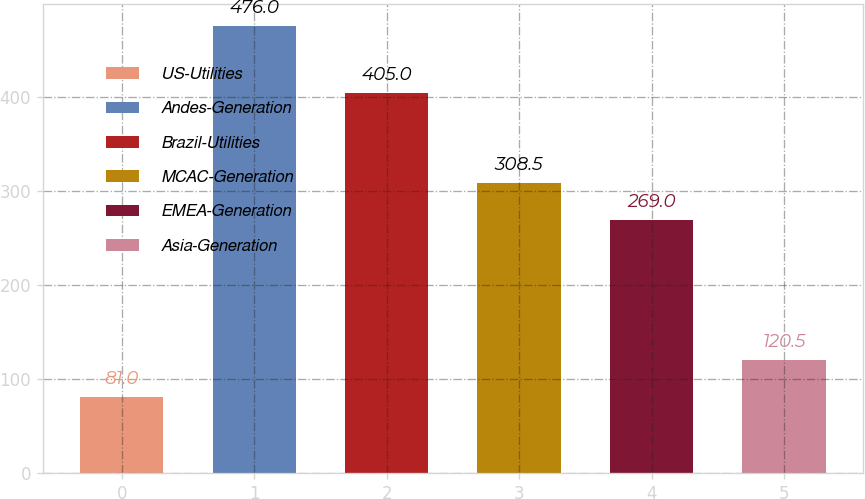Convert chart. <chart><loc_0><loc_0><loc_500><loc_500><bar_chart><fcel>US-Utilities<fcel>Andes-Generation<fcel>Brazil-Utilities<fcel>MCAC-Generation<fcel>EMEA-Generation<fcel>Asia-Generation<nl><fcel>81<fcel>476<fcel>405<fcel>308.5<fcel>269<fcel>120.5<nl></chart> 